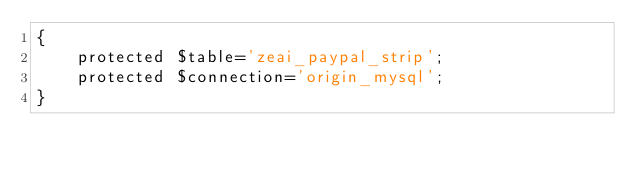Convert code to text. <code><loc_0><loc_0><loc_500><loc_500><_PHP_>{
    protected $table='zeai_paypal_strip';
    protected $connection='origin_mysql';
}</code> 